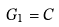Convert formula to latex. <formula><loc_0><loc_0><loc_500><loc_500>G _ { 1 } = C</formula> 